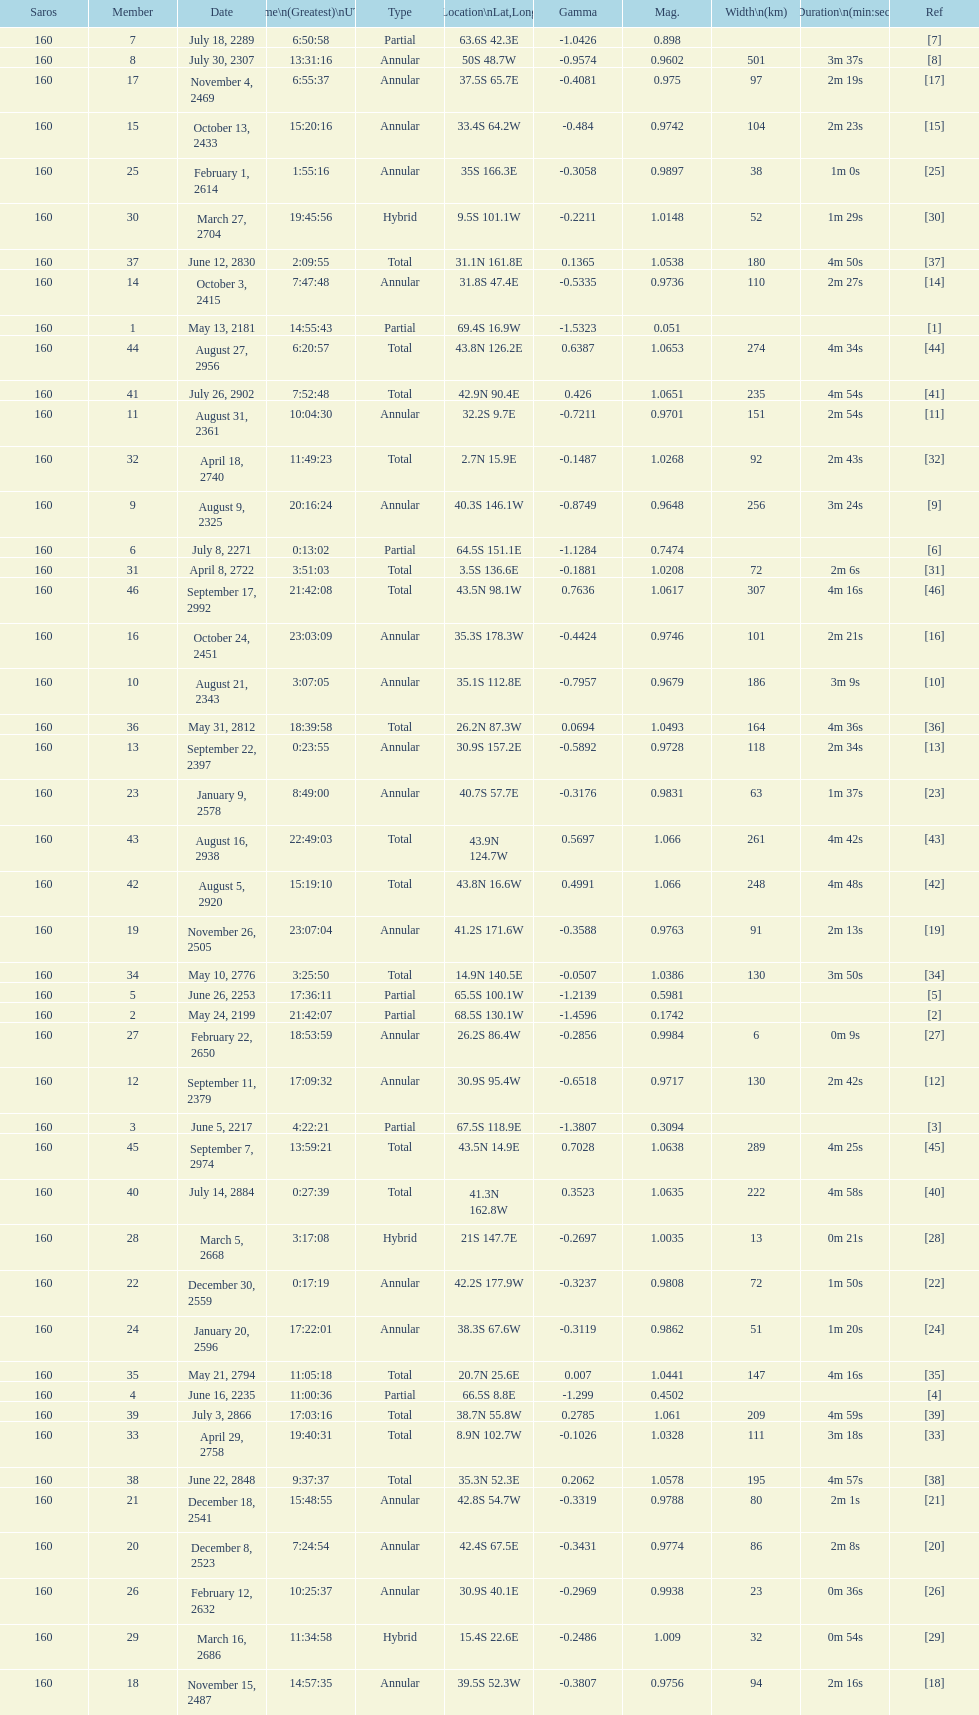When will the next solar saros be after the may 24, 2199 solar saros occurs? June 5, 2217. 